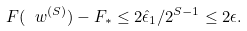<formula> <loc_0><loc_0><loc_500><loc_500>F ( \ w ^ { ( S ) } ) - F _ { * } \leq 2 \hat { \epsilon } _ { 1 } / 2 ^ { S - 1 } \leq 2 \epsilon .</formula> 